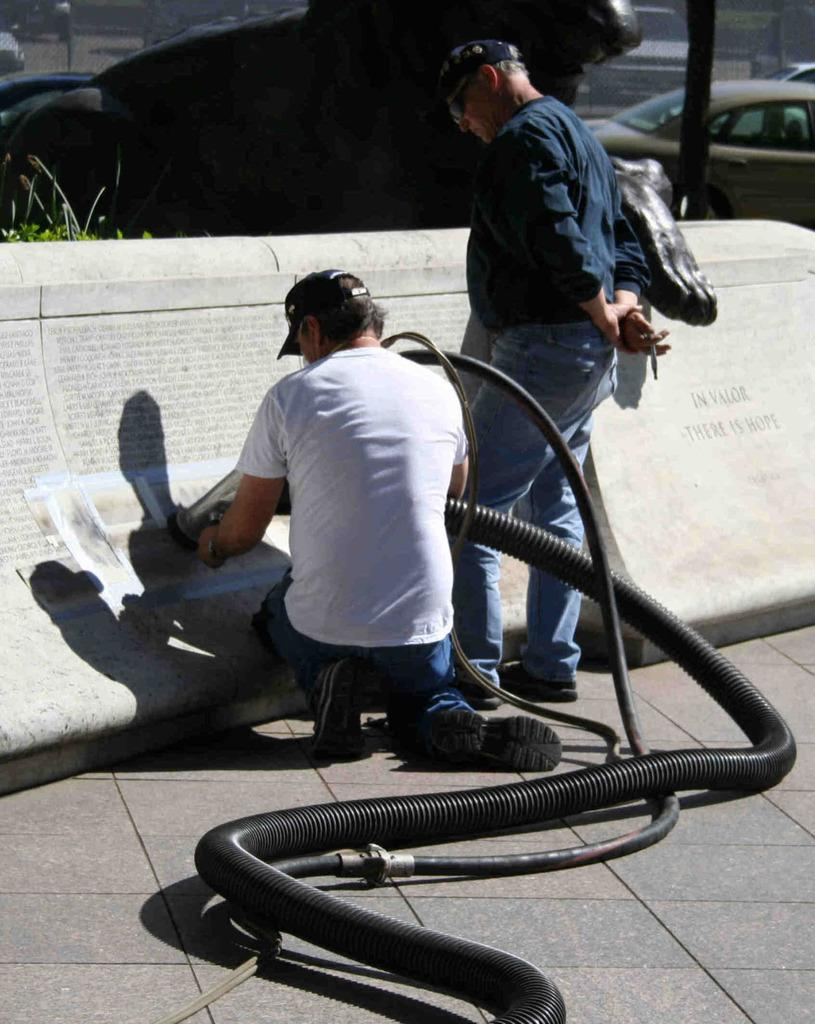What is the man holding in the image? The man is holding a black color cable in the image. What is the man doing while holding the cable? There is another man standing and looking at a wall in the image. What can be seen in the background of the image? A car is visible in the background of the image. What type of pancake is the man flipping in the image? There is no pancake present in the image; the man is holding a black color cable. How does the growth of the plants in the image contribute to the overall scene? There are no plants visible in the image, so it is not possible to discuss their growth. 